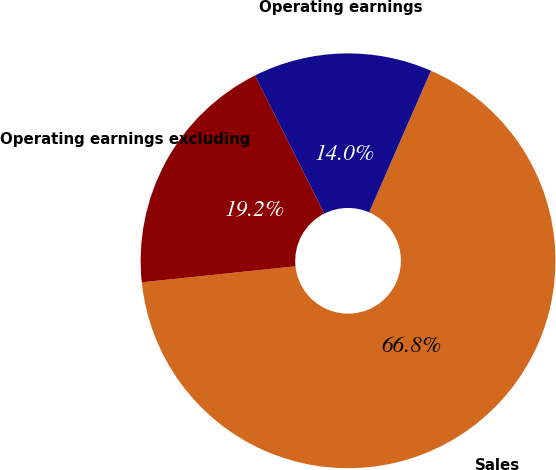<chart> <loc_0><loc_0><loc_500><loc_500><pie_chart><fcel>Sales<fcel>Operating earnings<fcel>Operating earnings excluding<nl><fcel>66.8%<fcel>13.96%<fcel>19.24%<nl></chart> 